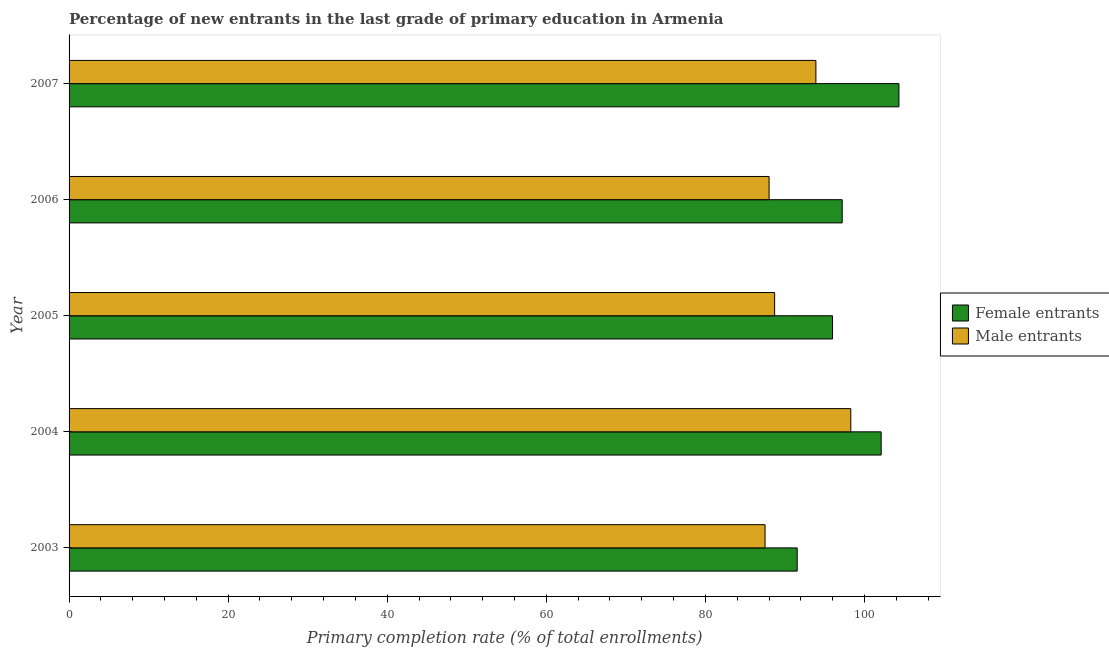How many groups of bars are there?
Provide a short and direct response. 5. Are the number of bars per tick equal to the number of legend labels?
Give a very brief answer. Yes. How many bars are there on the 4th tick from the bottom?
Your answer should be very brief. 2. What is the label of the 1st group of bars from the top?
Your answer should be very brief. 2007. In how many cases, is the number of bars for a given year not equal to the number of legend labels?
Give a very brief answer. 0. What is the primary completion rate of female entrants in 2004?
Your answer should be very brief. 102.09. Across all years, what is the maximum primary completion rate of female entrants?
Your answer should be very brief. 104.33. Across all years, what is the minimum primary completion rate of female entrants?
Offer a very short reply. 91.53. In which year was the primary completion rate of female entrants minimum?
Provide a succinct answer. 2003. What is the total primary completion rate of male entrants in the graph?
Ensure brevity in your answer.  456.35. What is the difference between the primary completion rate of female entrants in 2005 and that in 2006?
Keep it short and to the point. -1.22. What is the difference between the primary completion rate of male entrants in 2003 and the primary completion rate of female entrants in 2004?
Your response must be concise. -14.6. What is the average primary completion rate of female entrants per year?
Your answer should be compact. 98.22. In the year 2003, what is the difference between the primary completion rate of female entrants and primary completion rate of male entrants?
Make the answer very short. 4.04. In how many years, is the primary completion rate of female entrants greater than 80 %?
Provide a succinct answer. 5. What is the ratio of the primary completion rate of male entrants in 2004 to that in 2006?
Offer a very short reply. 1.12. What is the difference between the highest and the second highest primary completion rate of male entrants?
Ensure brevity in your answer.  4.39. What is the difference between the highest and the lowest primary completion rate of male entrants?
Make the answer very short. 10.78. In how many years, is the primary completion rate of male entrants greater than the average primary completion rate of male entrants taken over all years?
Ensure brevity in your answer.  2. What does the 2nd bar from the top in 2003 represents?
Your response must be concise. Female entrants. What does the 2nd bar from the bottom in 2004 represents?
Your answer should be very brief. Male entrants. Are all the bars in the graph horizontal?
Give a very brief answer. Yes. What is the difference between two consecutive major ticks on the X-axis?
Ensure brevity in your answer.  20. Does the graph contain any zero values?
Your answer should be very brief. No. How are the legend labels stacked?
Provide a short and direct response. Vertical. What is the title of the graph?
Provide a short and direct response. Percentage of new entrants in the last grade of primary education in Armenia. Does "Sanitation services" appear as one of the legend labels in the graph?
Your response must be concise. No. What is the label or title of the X-axis?
Make the answer very short. Primary completion rate (% of total enrollments). What is the Primary completion rate (% of total enrollments) of Female entrants in 2003?
Make the answer very short. 91.53. What is the Primary completion rate (% of total enrollments) of Male entrants in 2003?
Offer a terse response. 87.49. What is the Primary completion rate (% of total enrollments) of Female entrants in 2004?
Provide a succinct answer. 102.09. What is the Primary completion rate (% of total enrollments) in Male entrants in 2004?
Ensure brevity in your answer.  98.27. What is the Primary completion rate (% of total enrollments) of Female entrants in 2005?
Provide a short and direct response. 95.97. What is the Primary completion rate (% of total enrollments) of Male entrants in 2005?
Keep it short and to the point. 88.7. What is the Primary completion rate (% of total enrollments) in Female entrants in 2006?
Your answer should be compact. 97.19. What is the Primary completion rate (% of total enrollments) of Male entrants in 2006?
Keep it short and to the point. 88. What is the Primary completion rate (% of total enrollments) of Female entrants in 2007?
Your answer should be compact. 104.33. What is the Primary completion rate (% of total enrollments) of Male entrants in 2007?
Make the answer very short. 93.88. Across all years, what is the maximum Primary completion rate (% of total enrollments) in Female entrants?
Keep it short and to the point. 104.33. Across all years, what is the maximum Primary completion rate (% of total enrollments) of Male entrants?
Ensure brevity in your answer.  98.27. Across all years, what is the minimum Primary completion rate (% of total enrollments) in Female entrants?
Provide a short and direct response. 91.53. Across all years, what is the minimum Primary completion rate (% of total enrollments) in Male entrants?
Give a very brief answer. 87.49. What is the total Primary completion rate (% of total enrollments) in Female entrants in the graph?
Your answer should be compact. 491.12. What is the total Primary completion rate (% of total enrollments) in Male entrants in the graph?
Your answer should be compact. 456.35. What is the difference between the Primary completion rate (% of total enrollments) in Female entrants in 2003 and that in 2004?
Provide a succinct answer. -10.56. What is the difference between the Primary completion rate (% of total enrollments) in Male entrants in 2003 and that in 2004?
Make the answer very short. -10.78. What is the difference between the Primary completion rate (% of total enrollments) of Female entrants in 2003 and that in 2005?
Ensure brevity in your answer.  -4.44. What is the difference between the Primary completion rate (% of total enrollments) in Male entrants in 2003 and that in 2005?
Your answer should be compact. -1.2. What is the difference between the Primary completion rate (% of total enrollments) in Female entrants in 2003 and that in 2006?
Provide a succinct answer. -5.66. What is the difference between the Primary completion rate (% of total enrollments) of Male entrants in 2003 and that in 2006?
Provide a succinct answer. -0.51. What is the difference between the Primary completion rate (% of total enrollments) of Female entrants in 2003 and that in 2007?
Your answer should be compact. -12.79. What is the difference between the Primary completion rate (% of total enrollments) in Male entrants in 2003 and that in 2007?
Ensure brevity in your answer.  -6.39. What is the difference between the Primary completion rate (% of total enrollments) in Female entrants in 2004 and that in 2005?
Ensure brevity in your answer.  6.12. What is the difference between the Primary completion rate (% of total enrollments) in Male entrants in 2004 and that in 2005?
Your response must be concise. 9.58. What is the difference between the Primary completion rate (% of total enrollments) in Female entrants in 2004 and that in 2006?
Make the answer very short. 4.9. What is the difference between the Primary completion rate (% of total enrollments) in Male entrants in 2004 and that in 2006?
Provide a succinct answer. 10.27. What is the difference between the Primary completion rate (% of total enrollments) in Female entrants in 2004 and that in 2007?
Make the answer very short. -2.23. What is the difference between the Primary completion rate (% of total enrollments) of Male entrants in 2004 and that in 2007?
Your answer should be very brief. 4.39. What is the difference between the Primary completion rate (% of total enrollments) of Female entrants in 2005 and that in 2006?
Your answer should be very brief. -1.22. What is the difference between the Primary completion rate (% of total enrollments) of Male entrants in 2005 and that in 2006?
Offer a terse response. 0.69. What is the difference between the Primary completion rate (% of total enrollments) of Female entrants in 2005 and that in 2007?
Provide a short and direct response. -8.35. What is the difference between the Primary completion rate (% of total enrollments) of Male entrants in 2005 and that in 2007?
Provide a succinct answer. -5.19. What is the difference between the Primary completion rate (% of total enrollments) of Female entrants in 2006 and that in 2007?
Provide a succinct answer. -7.13. What is the difference between the Primary completion rate (% of total enrollments) of Male entrants in 2006 and that in 2007?
Offer a terse response. -5.88. What is the difference between the Primary completion rate (% of total enrollments) in Female entrants in 2003 and the Primary completion rate (% of total enrollments) in Male entrants in 2004?
Give a very brief answer. -6.74. What is the difference between the Primary completion rate (% of total enrollments) of Female entrants in 2003 and the Primary completion rate (% of total enrollments) of Male entrants in 2005?
Offer a terse response. 2.84. What is the difference between the Primary completion rate (% of total enrollments) of Female entrants in 2003 and the Primary completion rate (% of total enrollments) of Male entrants in 2006?
Provide a short and direct response. 3.53. What is the difference between the Primary completion rate (% of total enrollments) of Female entrants in 2003 and the Primary completion rate (% of total enrollments) of Male entrants in 2007?
Offer a very short reply. -2.35. What is the difference between the Primary completion rate (% of total enrollments) in Female entrants in 2004 and the Primary completion rate (% of total enrollments) in Male entrants in 2005?
Your response must be concise. 13.39. What is the difference between the Primary completion rate (% of total enrollments) in Female entrants in 2004 and the Primary completion rate (% of total enrollments) in Male entrants in 2006?
Your answer should be compact. 14.09. What is the difference between the Primary completion rate (% of total enrollments) in Female entrants in 2004 and the Primary completion rate (% of total enrollments) in Male entrants in 2007?
Your answer should be very brief. 8.21. What is the difference between the Primary completion rate (% of total enrollments) in Female entrants in 2005 and the Primary completion rate (% of total enrollments) in Male entrants in 2006?
Give a very brief answer. 7.97. What is the difference between the Primary completion rate (% of total enrollments) of Female entrants in 2005 and the Primary completion rate (% of total enrollments) of Male entrants in 2007?
Provide a succinct answer. 2.09. What is the difference between the Primary completion rate (% of total enrollments) of Female entrants in 2006 and the Primary completion rate (% of total enrollments) of Male entrants in 2007?
Your answer should be compact. 3.31. What is the average Primary completion rate (% of total enrollments) in Female entrants per year?
Your response must be concise. 98.22. What is the average Primary completion rate (% of total enrollments) in Male entrants per year?
Provide a short and direct response. 91.27. In the year 2003, what is the difference between the Primary completion rate (% of total enrollments) in Female entrants and Primary completion rate (% of total enrollments) in Male entrants?
Your answer should be compact. 4.04. In the year 2004, what is the difference between the Primary completion rate (% of total enrollments) in Female entrants and Primary completion rate (% of total enrollments) in Male entrants?
Your answer should be very brief. 3.82. In the year 2005, what is the difference between the Primary completion rate (% of total enrollments) of Female entrants and Primary completion rate (% of total enrollments) of Male entrants?
Offer a terse response. 7.28. In the year 2006, what is the difference between the Primary completion rate (% of total enrollments) in Female entrants and Primary completion rate (% of total enrollments) in Male entrants?
Offer a terse response. 9.19. In the year 2007, what is the difference between the Primary completion rate (% of total enrollments) in Female entrants and Primary completion rate (% of total enrollments) in Male entrants?
Offer a terse response. 10.44. What is the ratio of the Primary completion rate (% of total enrollments) of Female entrants in 2003 to that in 2004?
Offer a very short reply. 0.9. What is the ratio of the Primary completion rate (% of total enrollments) in Male entrants in 2003 to that in 2004?
Your response must be concise. 0.89. What is the ratio of the Primary completion rate (% of total enrollments) in Female entrants in 2003 to that in 2005?
Offer a terse response. 0.95. What is the ratio of the Primary completion rate (% of total enrollments) of Male entrants in 2003 to that in 2005?
Provide a succinct answer. 0.99. What is the ratio of the Primary completion rate (% of total enrollments) of Female entrants in 2003 to that in 2006?
Provide a succinct answer. 0.94. What is the ratio of the Primary completion rate (% of total enrollments) in Female entrants in 2003 to that in 2007?
Make the answer very short. 0.88. What is the ratio of the Primary completion rate (% of total enrollments) of Male entrants in 2003 to that in 2007?
Offer a terse response. 0.93. What is the ratio of the Primary completion rate (% of total enrollments) in Female entrants in 2004 to that in 2005?
Keep it short and to the point. 1.06. What is the ratio of the Primary completion rate (% of total enrollments) of Male entrants in 2004 to that in 2005?
Ensure brevity in your answer.  1.11. What is the ratio of the Primary completion rate (% of total enrollments) of Female entrants in 2004 to that in 2006?
Keep it short and to the point. 1.05. What is the ratio of the Primary completion rate (% of total enrollments) in Male entrants in 2004 to that in 2006?
Provide a succinct answer. 1.12. What is the ratio of the Primary completion rate (% of total enrollments) in Female entrants in 2004 to that in 2007?
Offer a terse response. 0.98. What is the ratio of the Primary completion rate (% of total enrollments) of Male entrants in 2004 to that in 2007?
Provide a short and direct response. 1.05. What is the ratio of the Primary completion rate (% of total enrollments) in Female entrants in 2005 to that in 2006?
Offer a very short reply. 0.99. What is the ratio of the Primary completion rate (% of total enrollments) of Male entrants in 2005 to that in 2006?
Your answer should be compact. 1.01. What is the ratio of the Primary completion rate (% of total enrollments) of Female entrants in 2005 to that in 2007?
Provide a short and direct response. 0.92. What is the ratio of the Primary completion rate (% of total enrollments) of Male entrants in 2005 to that in 2007?
Offer a very short reply. 0.94. What is the ratio of the Primary completion rate (% of total enrollments) in Female entrants in 2006 to that in 2007?
Your answer should be very brief. 0.93. What is the ratio of the Primary completion rate (% of total enrollments) of Male entrants in 2006 to that in 2007?
Your answer should be compact. 0.94. What is the difference between the highest and the second highest Primary completion rate (% of total enrollments) of Female entrants?
Provide a short and direct response. 2.23. What is the difference between the highest and the second highest Primary completion rate (% of total enrollments) of Male entrants?
Offer a terse response. 4.39. What is the difference between the highest and the lowest Primary completion rate (% of total enrollments) in Female entrants?
Offer a very short reply. 12.79. What is the difference between the highest and the lowest Primary completion rate (% of total enrollments) of Male entrants?
Ensure brevity in your answer.  10.78. 